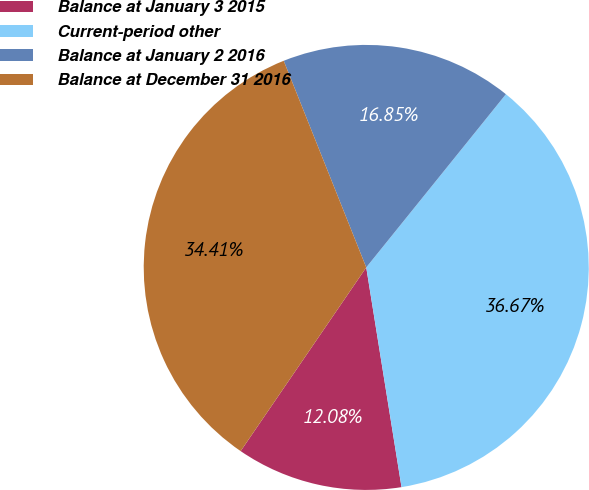Convert chart to OTSL. <chart><loc_0><loc_0><loc_500><loc_500><pie_chart><fcel>Balance at January 3 2015<fcel>Current-period other<fcel>Balance at January 2 2016<fcel>Balance at December 31 2016<nl><fcel>12.08%<fcel>36.67%<fcel>16.85%<fcel>34.41%<nl></chart> 